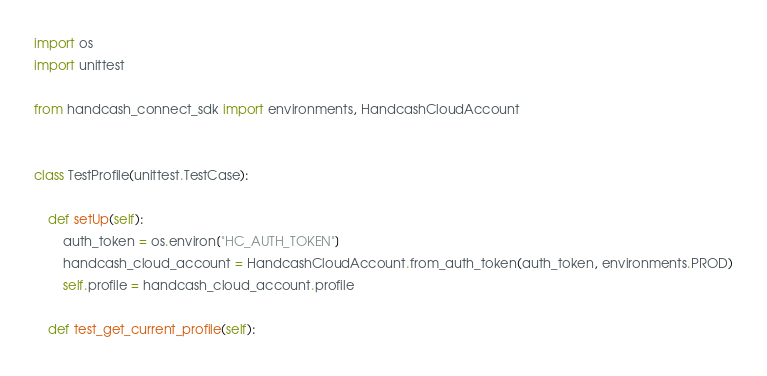<code> <loc_0><loc_0><loc_500><loc_500><_Python_>import os
import unittest

from handcash_connect_sdk import environments, HandcashCloudAccount


class TestProfile(unittest.TestCase):

    def setUp(self):
        auth_token = os.environ["HC_AUTH_TOKEN"]
        handcash_cloud_account = HandcashCloudAccount.from_auth_token(auth_token, environments.PROD)
        self.profile = handcash_cloud_account.profile

    def test_get_current_profile(self):</code> 